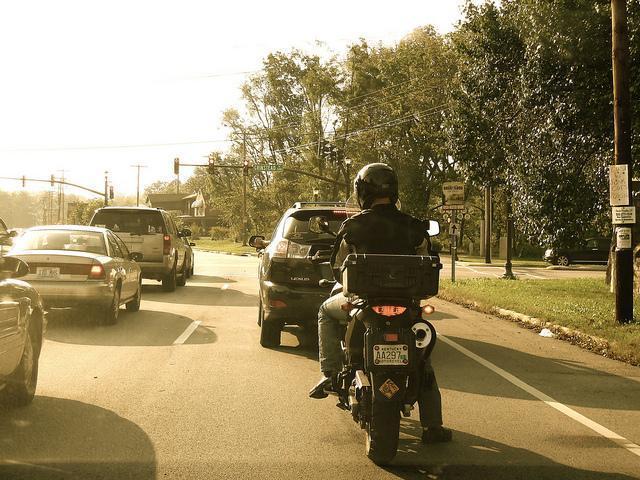How many cars are there?
Give a very brief answer. 4. How many birds are flying in the picture?
Give a very brief answer. 0. 